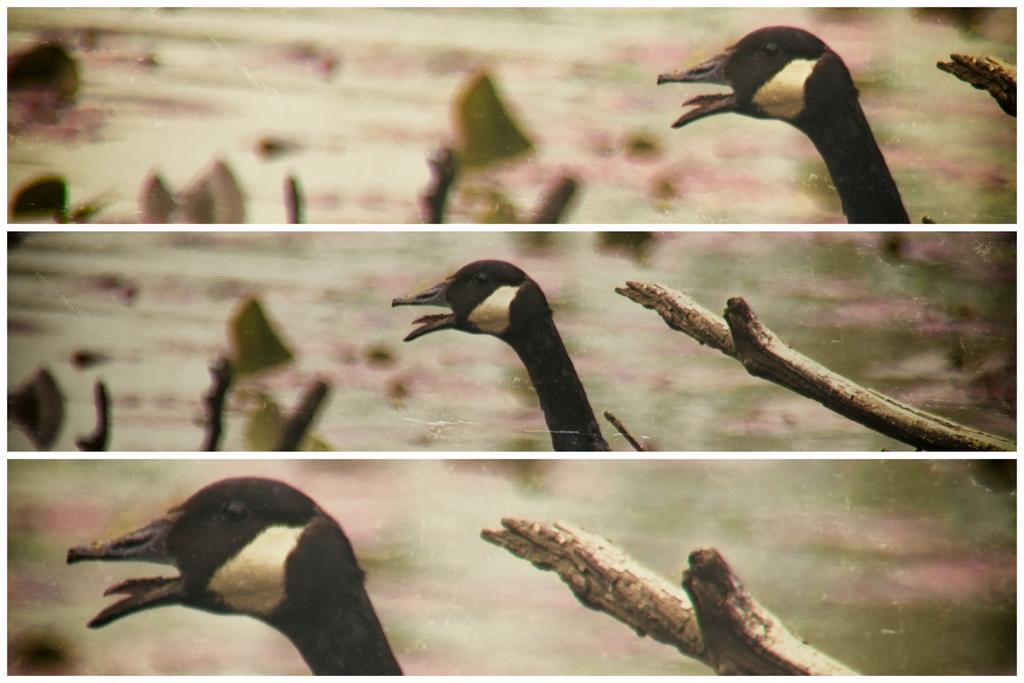What is the main subject of the picture? The main subject of the picture is a collage of images. Can you describe any specific images in the collage? Yes, the collage includes an image of a duck's neck. What type of material is used in the collage? The collage includes wooden pieces. How does the duck in the collage adjust its sense of balance? There is no duck present in the image, as it is a collage that includes an image of a duck's neck. The duck's sense of balance cannot be determined from the image. How many rings are visible in the collage? There are no rings visible in the collage; it includes an image of a duck's neck and wooden pieces. 